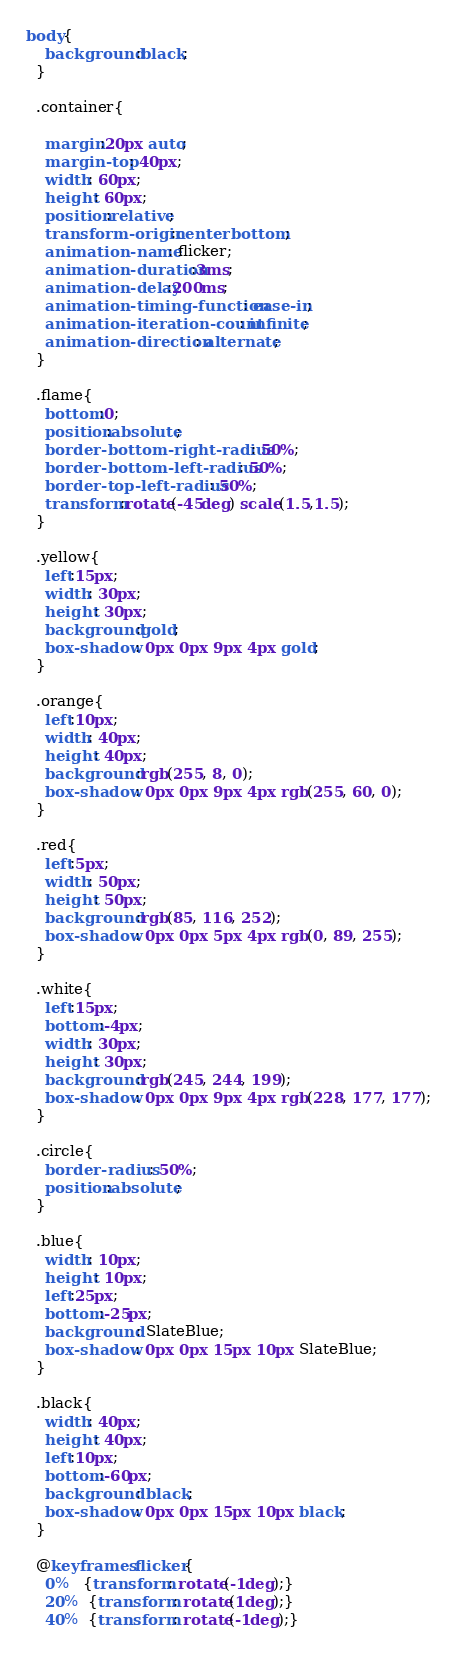Convert code to text. <code><loc_0><loc_0><loc_500><loc_500><_CSS_>body{
    background:black;
  }
  
  .container{

    margin:20px auto;
    margin-top: 40px;
    width: 60px;
    height: 60px;
    position:relative;
    transform-origin:center bottom;
    animation-name: flicker;
    animation-duration:3ms;
    animation-delay:200ms;
    animation-timing-function: ease-in;
    animation-iteration-count: infinite;
    animation-direction: alternate;
  }
  
  .flame{
    bottom:0;
    position:absolute;
    border-bottom-right-radius: 50%;
    border-bottom-left-radius: 50%;
    border-top-left-radius: 50%;
    transform:rotate(-45deg) scale(1.5,1.5);
  }
  
  .yellow{
    left:15px; 
    width: 30px;
    height: 30px;
    background:gold;
    box-shadow: 0px 0px 9px 4px gold;
  }
  
  .orange{
    left:10px; 
    width: 40px;
    height: 40px;
    background:rgb(255, 8, 0);
    box-shadow: 0px 0px 9px 4px rgb(255, 60, 0);
  }
  
  .red{
    left:5px;
    width: 50px;
    height: 50px;
    background:rgb(85, 116, 252);
    box-shadow: 0px 0px 5px 4px rgb(0, 89, 255);
  }
  
  .white{
    left:15px; 
    bottom:-4px;
    width: 30px;
    height: 30px;
    background:rgb(245, 244, 199);
    box-shadow: 0px 0px 9px 4px rgb(228, 177, 177);
  }
  
  .circle{
    border-radius: 50%;
    position:absolute;  
  }
  
  .blue{
    width: 10px;
    height: 10px;
    left:25px;
    bottom:-25px; 
    background: SlateBlue;
    box-shadow: 0px 0px 15px 10px SlateBlue;
  }
  
  .black{
    width: 40px;
    height: 40px;
    left:10px;
    bottom:-60px;  
    background: black;
    box-shadow: 0px 0px 15px 10px black;
  }
  
  @keyframes flicker{
    0%   {transform: rotate(-1deg);}
    20%  {transform: rotate(1deg);}
    40%  {transform: rotate(-1deg);}</code> 